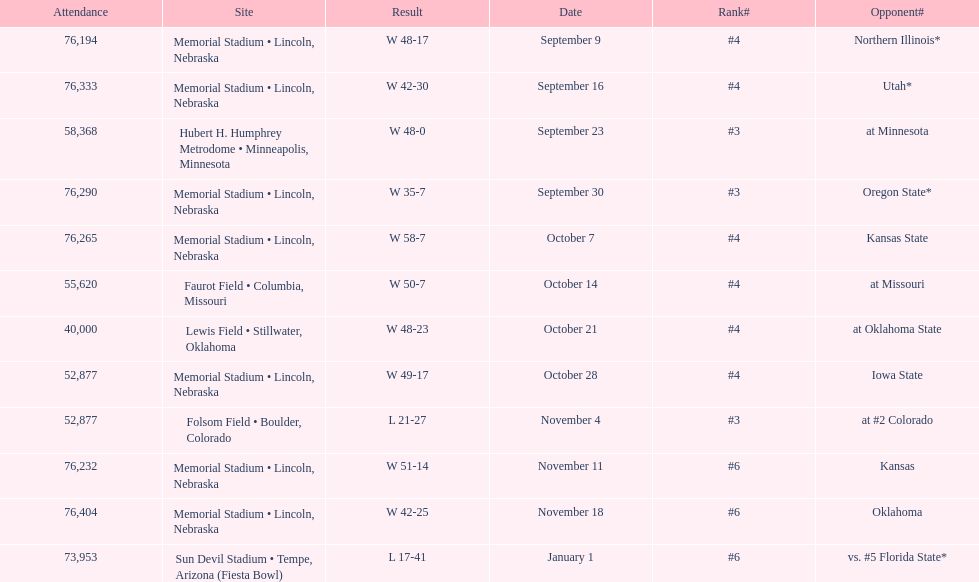Which month is listed the least on this chart? January. 